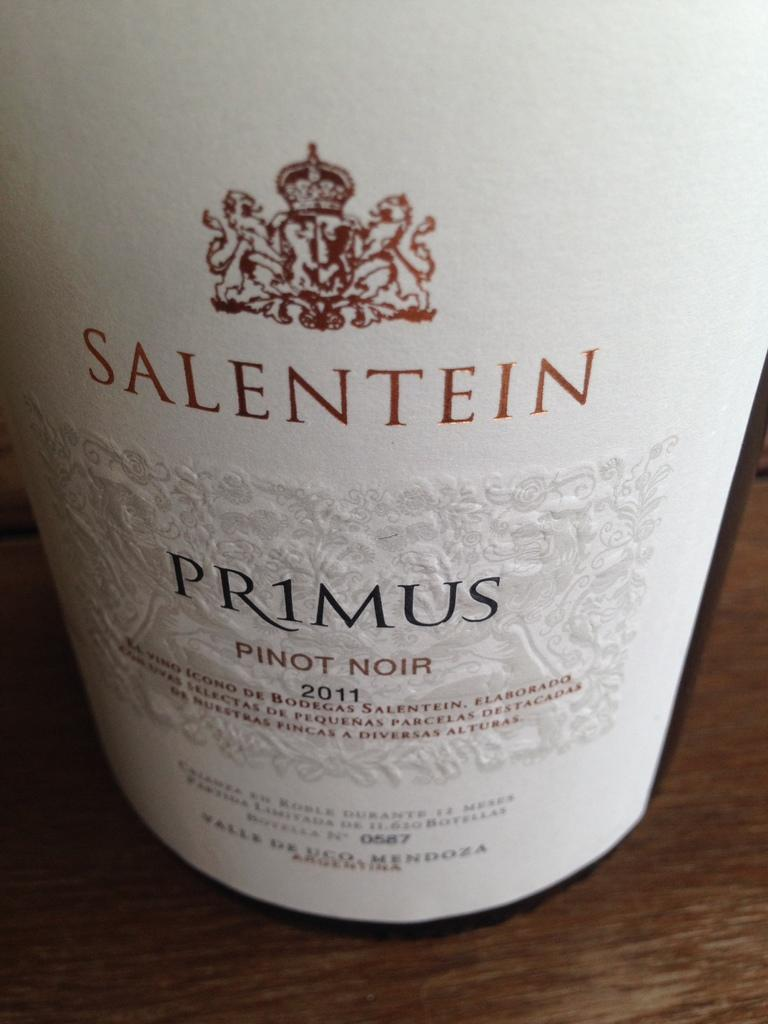<image>
Share a concise interpretation of the image provided. The label for a bottle of Salentein Primus Pinot Noir wine. 